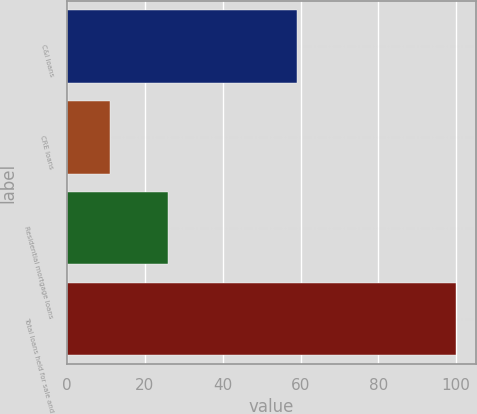<chart> <loc_0><loc_0><loc_500><loc_500><bar_chart><fcel>C&I loans<fcel>CRE loans<fcel>Residential mortgage loans<fcel>Total loans held for sale and<nl><fcel>59<fcel>11<fcel>26<fcel>100<nl></chart> 